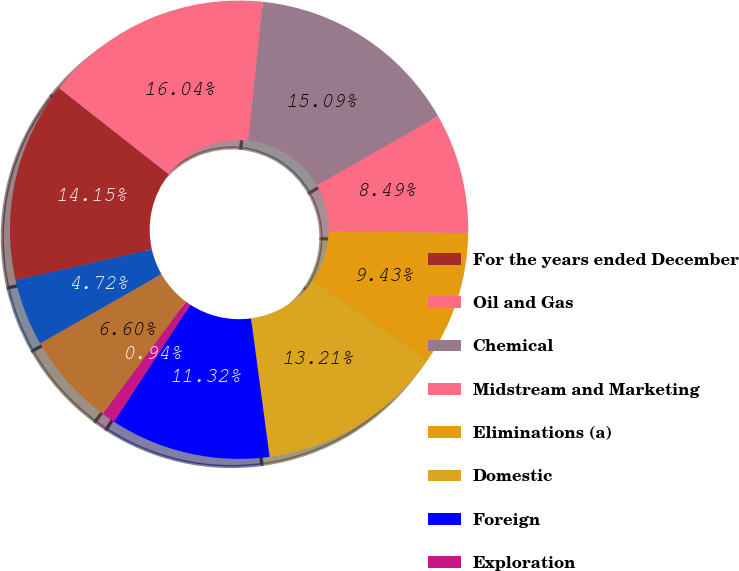<chart> <loc_0><loc_0><loc_500><loc_500><pie_chart><fcel>For the years ended December<fcel>Oil and Gas<fcel>Chemical<fcel>Midstream and Marketing<fcel>Eliminations (a)<fcel>Domestic<fcel>Foreign<fcel>Exploration<fcel>Oil and Gas (bcd)<fcel>Chemical (e)<nl><fcel>14.15%<fcel>16.04%<fcel>15.09%<fcel>8.49%<fcel>9.43%<fcel>13.21%<fcel>11.32%<fcel>0.94%<fcel>6.6%<fcel>4.72%<nl></chart> 